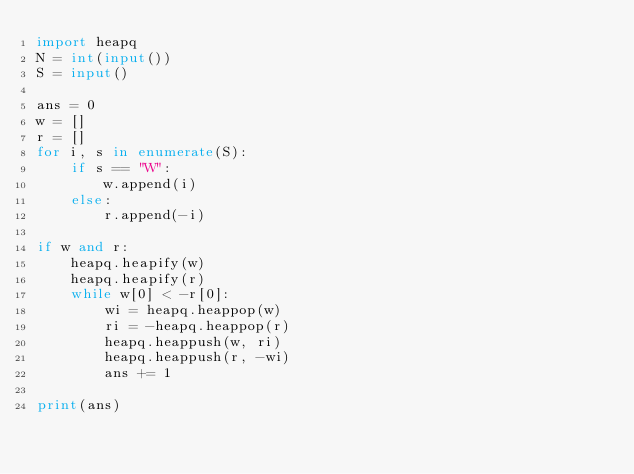<code> <loc_0><loc_0><loc_500><loc_500><_Python_>import heapq
N = int(input())
S = input()

ans = 0
w = []
r = []
for i, s in enumerate(S):
    if s == "W":
        w.append(i)
    else:
        r.append(-i)

if w and r:
    heapq.heapify(w)
    heapq.heapify(r)
    while w[0] < -r[0]:
        wi = heapq.heappop(w)
        ri = -heapq.heappop(r)
        heapq.heappush(w, ri)
        heapq.heappush(r, -wi)
        ans += 1

print(ans)</code> 